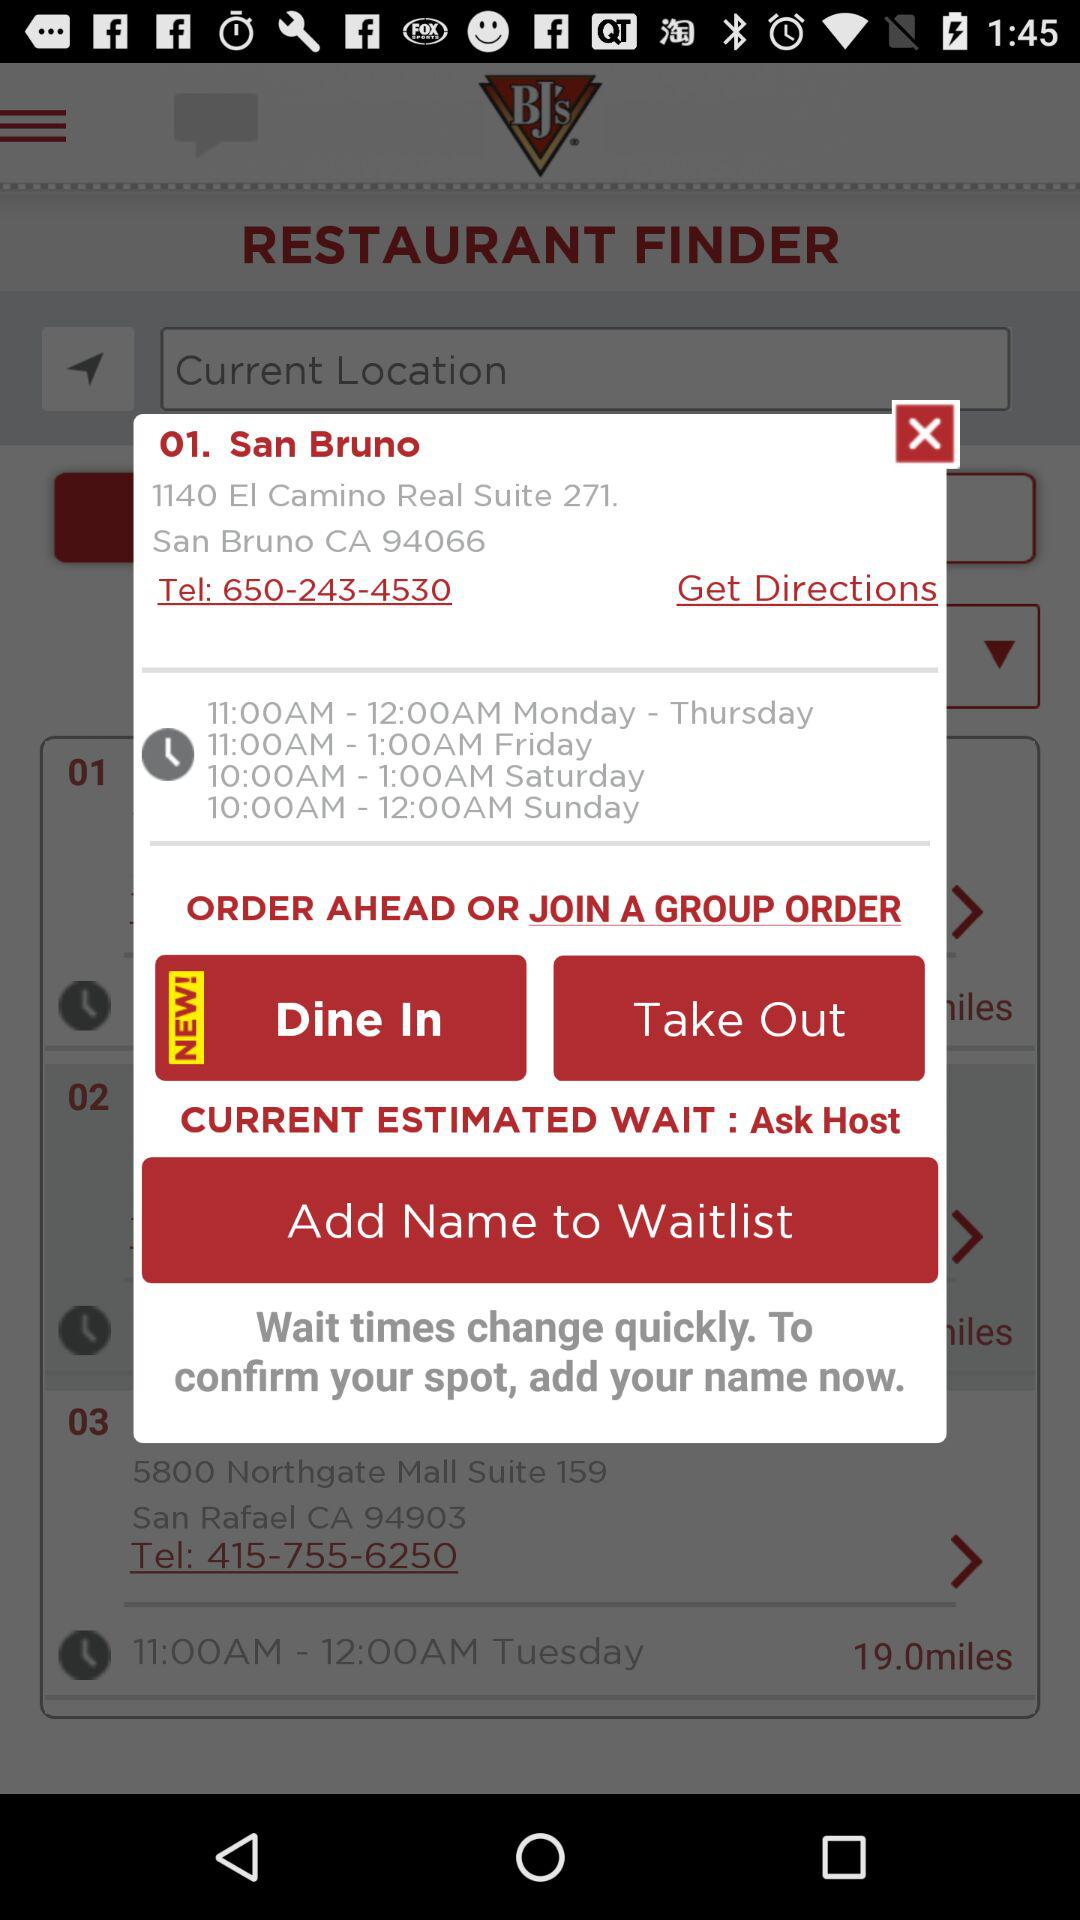What is the contact number? The contact numbers are 650-243-4530 and 415-755-6250. 